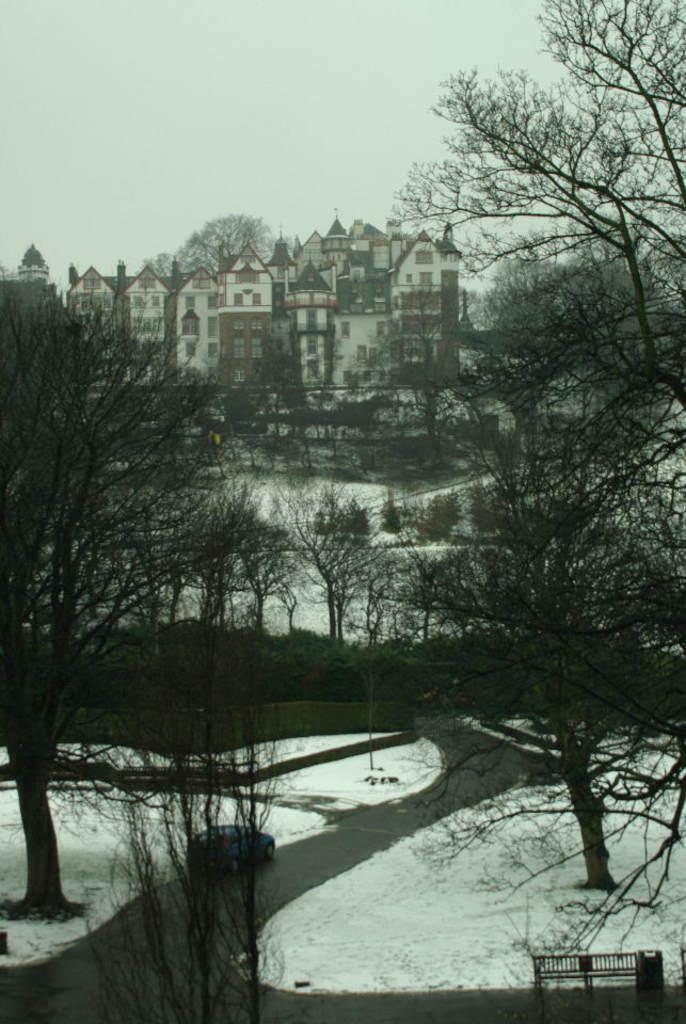Describe this image in one or two sentences. In this image I can see number of trees, a building and ground full of snow. I can also see a car over there. 